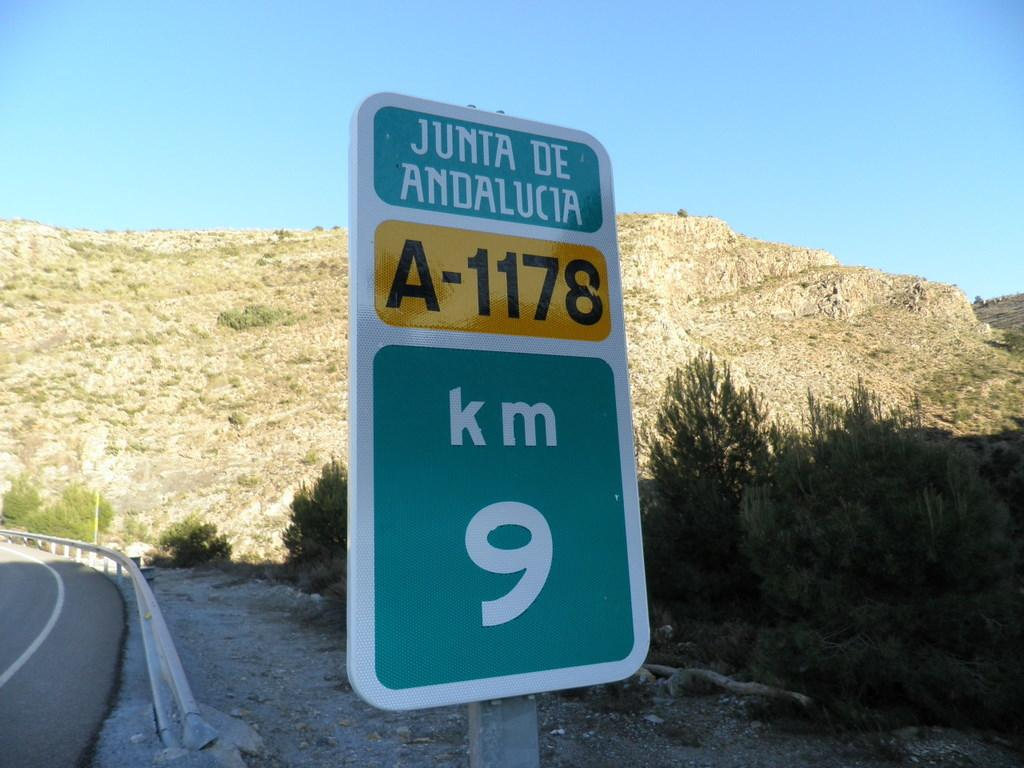<image>
Write a terse but informative summary of the picture. Junta De Andalucia A-1178 road sign showing 9 km before a curve in the road in the desert 